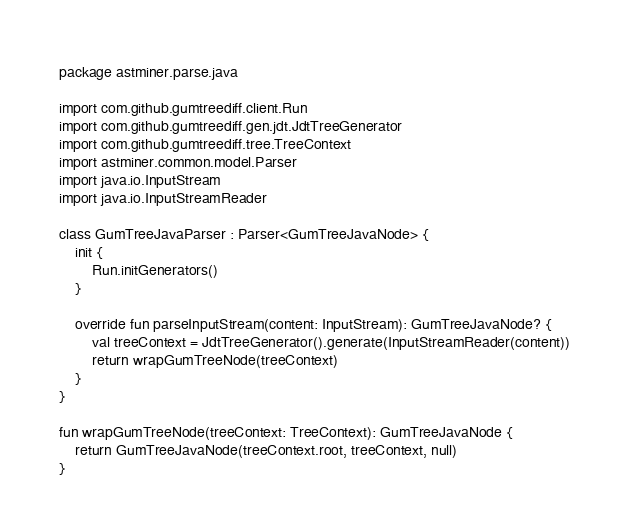<code> <loc_0><loc_0><loc_500><loc_500><_Kotlin_>package astminer.parse.java

import com.github.gumtreediff.client.Run
import com.github.gumtreediff.gen.jdt.JdtTreeGenerator
import com.github.gumtreediff.tree.TreeContext
import astminer.common.model.Parser
import java.io.InputStream
import java.io.InputStreamReader

class GumTreeJavaParser : Parser<GumTreeJavaNode> {
    init {
        Run.initGenerators()
    }

    override fun parseInputStream(content: InputStream): GumTreeJavaNode? {
        val treeContext = JdtTreeGenerator().generate(InputStreamReader(content))
        return wrapGumTreeNode(treeContext)
    }
}

fun wrapGumTreeNode(treeContext: TreeContext): GumTreeJavaNode {
    return GumTreeJavaNode(treeContext.root, treeContext, null)
}</code> 